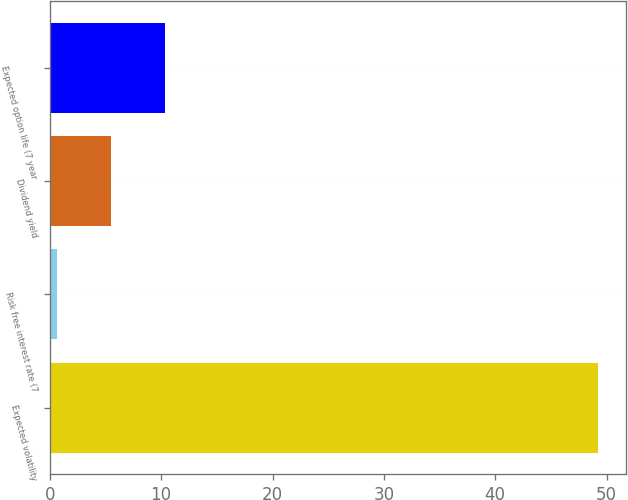<chart> <loc_0><loc_0><loc_500><loc_500><bar_chart><fcel>Expected volatility<fcel>Risk free interest rate (7<fcel>Dividend yield<fcel>Expected option life (7 year<nl><fcel>49.26<fcel>0.63<fcel>5.49<fcel>10.35<nl></chart> 